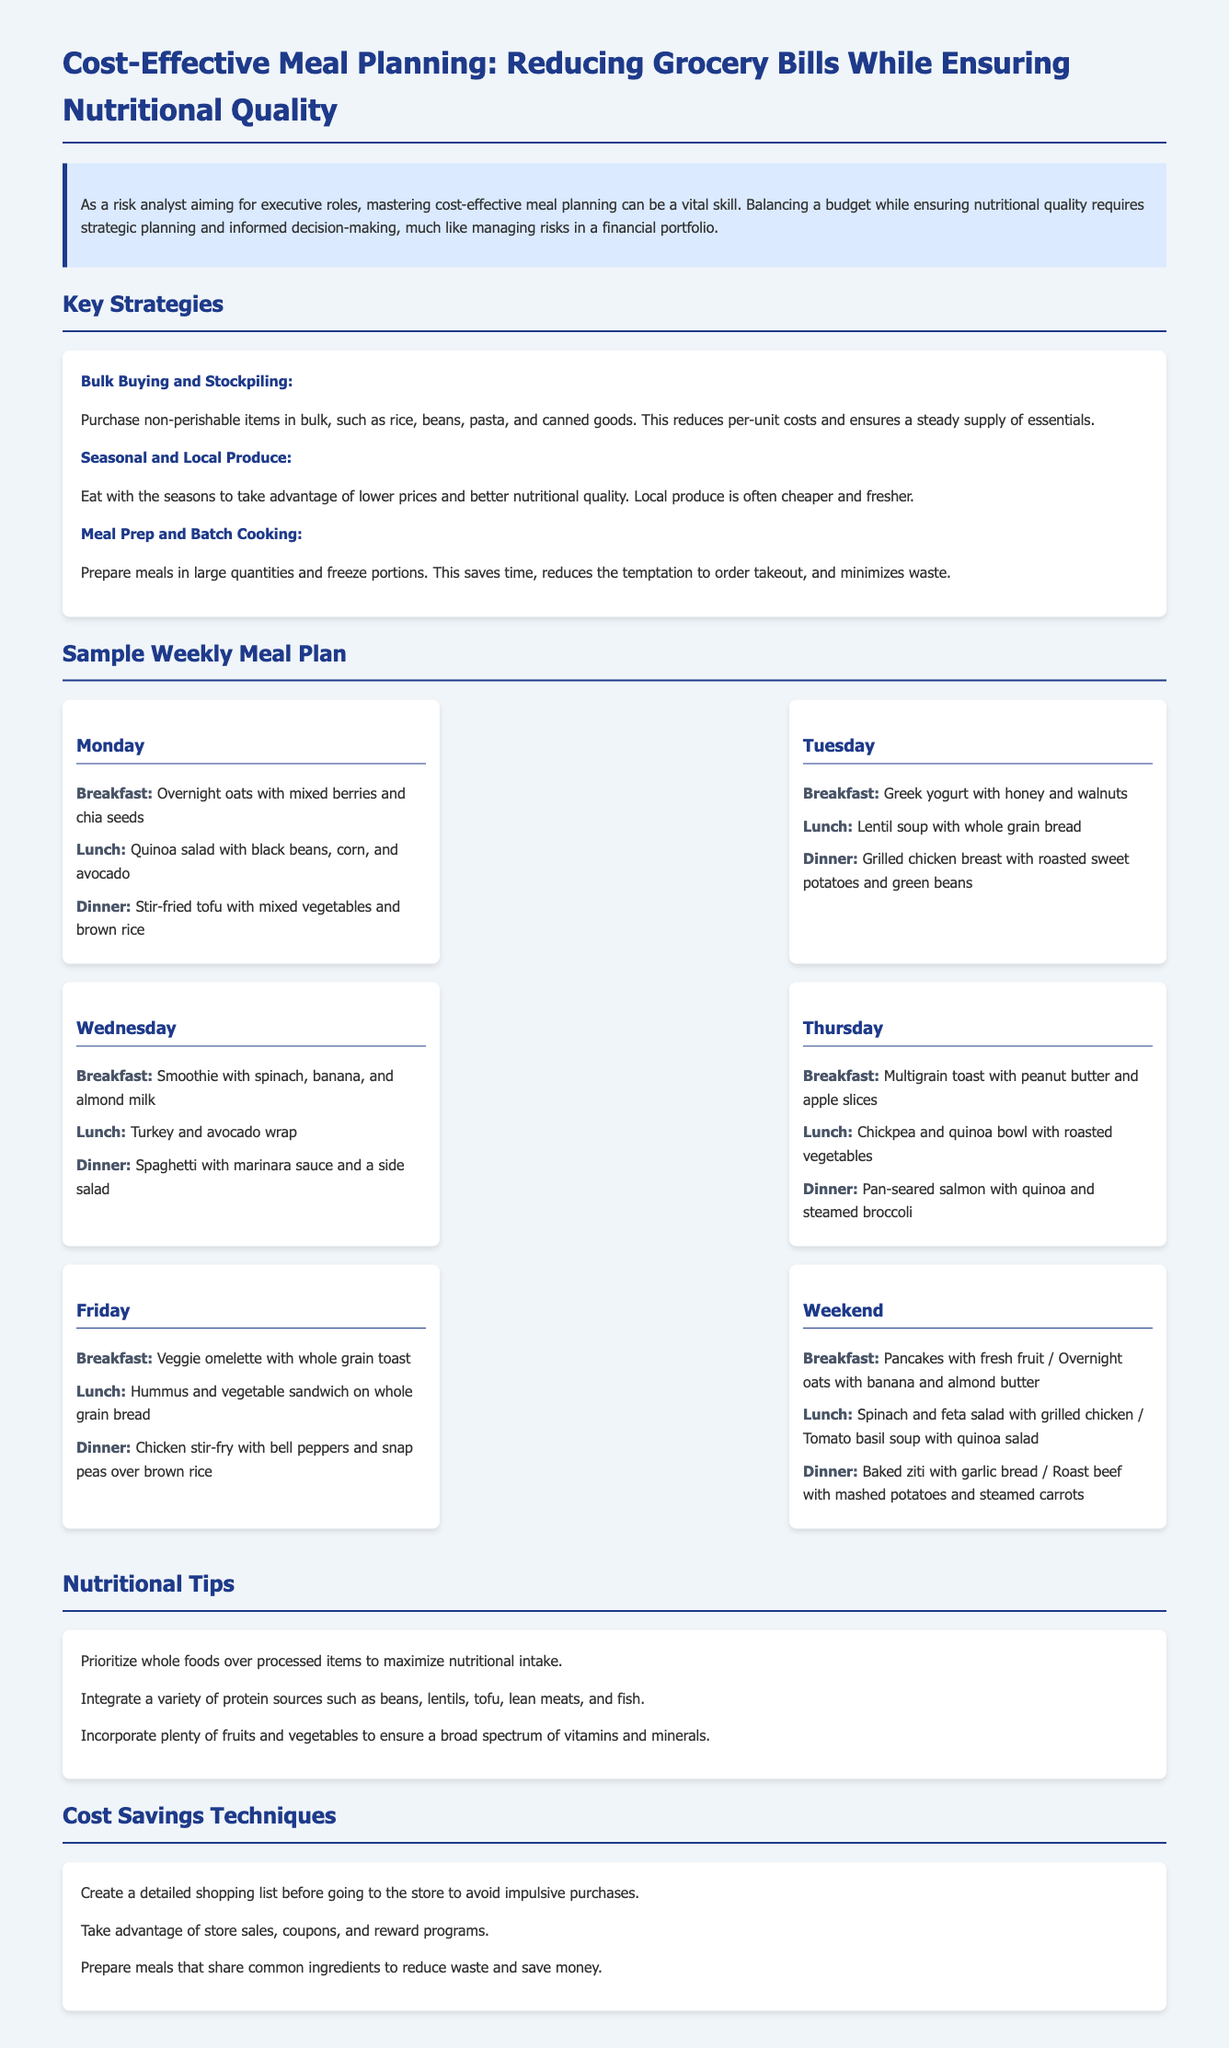What is the title of the document? The title of the document is found in the header section, providing a brief overview of the content.
Answer: Cost-Effective Meal Planning: Reducing Grocery Bills While Ensuring Nutritional Quality How many key strategies are listed? The document lists several strategies under the Key Strategies section, which are identified by bullet points.
Answer: 3 What is one meal mentioned for Tuesday's dinner? The document provides specific meals for each day, including options for Tuesday's dinner meal.
Answer: Grilled chicken breast with roasted sweet potatoes and green beans What is one nutritional tip provided? The document includes various tips under the Nutritional Tips section, which can be found as listed points.
Answer: Prioritize whole foods over processed items to maximize nutritional intake What is one cost savings technique mentioned? The document discusses techniques to save costs, which are detailed in the Cost Savings Techniques section.
Answer: Create a detailed shopping list before going to the store to avoid impulsive purchases What is the meal for breakfast on Wednesday? Each day's meals are distinctly identified, showing specific meals for breakfast throughout the week.
Answer: Smoothie with spinach, banana, and almond milk 